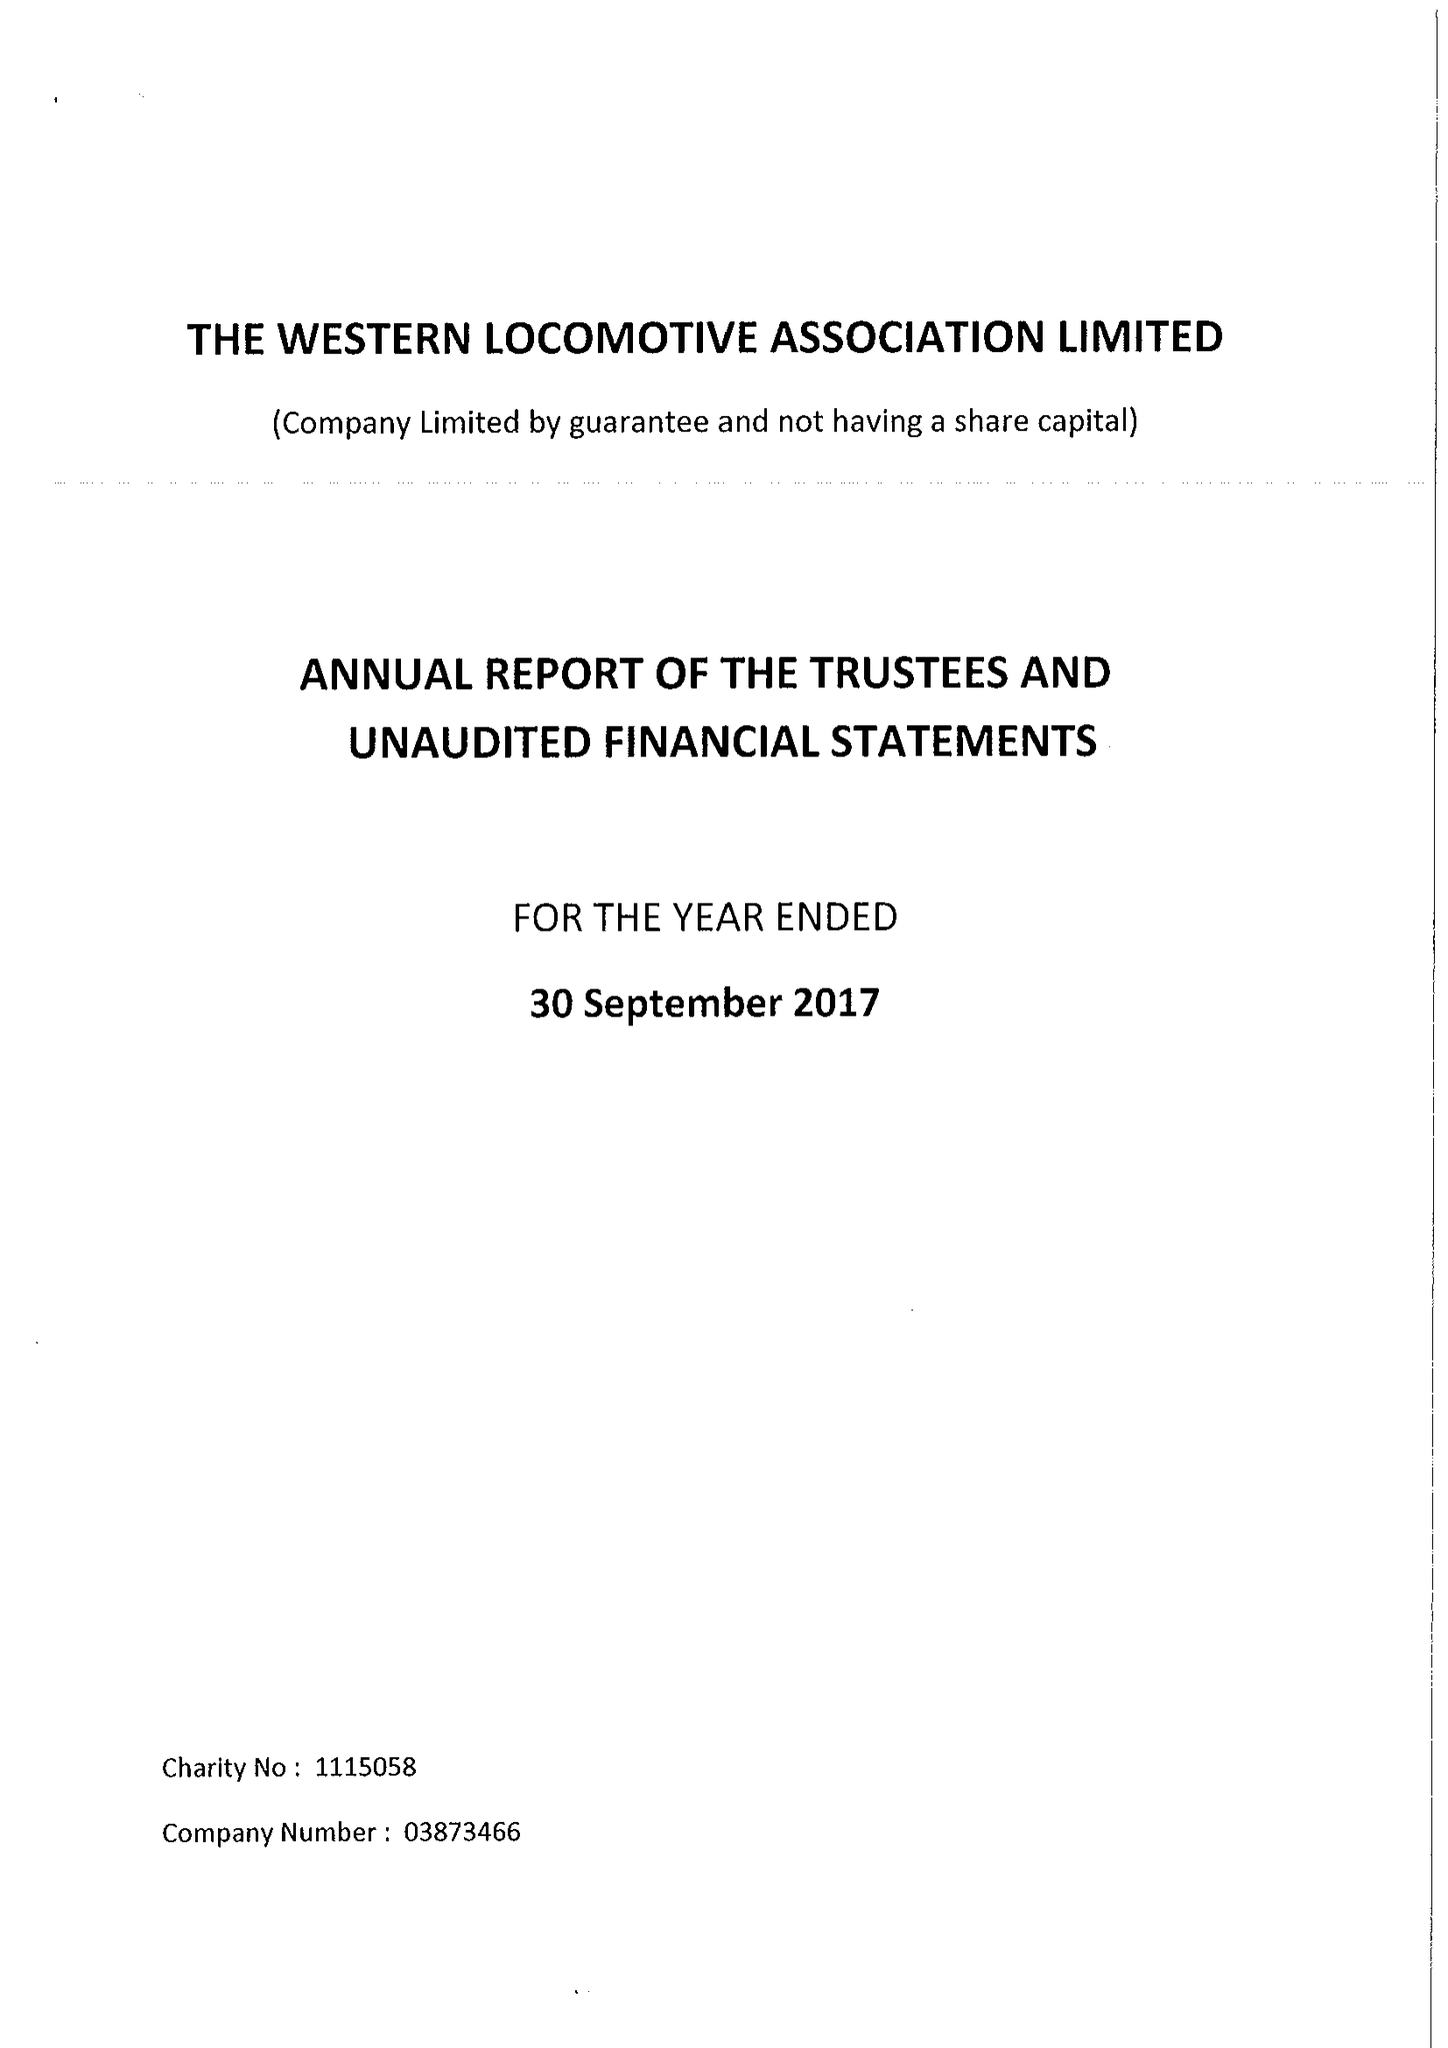What is the value for the spending_annually_in_british_pounds?
Answer the question using a single word or phrase. 39419.00 